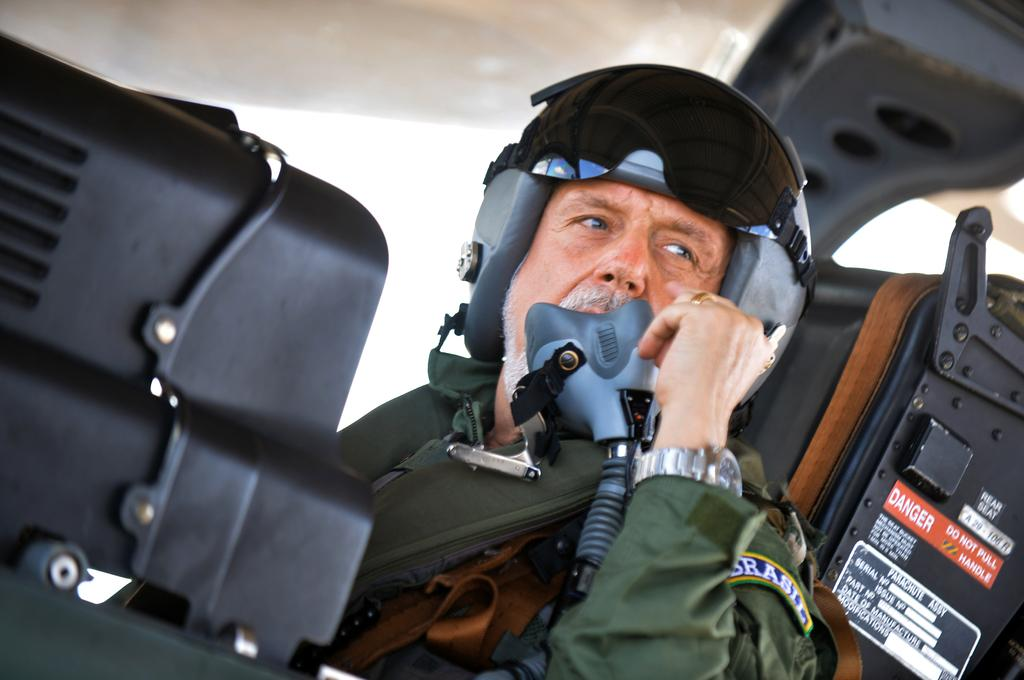Who is present in the image? There is a man in the image. What is the man wearing on his head? The man is wearing a helmet. Where does it seem the image was taken? The image appears to be taken inside a chopper. What color is the man's dress? The man is wearing a green dress. What type of hose can be seen in the image? There is no hose present in the image. How many pizzas are visible on the man's dress? There are no pizzas depicted on the man's dress; he is wearing a green dress. 